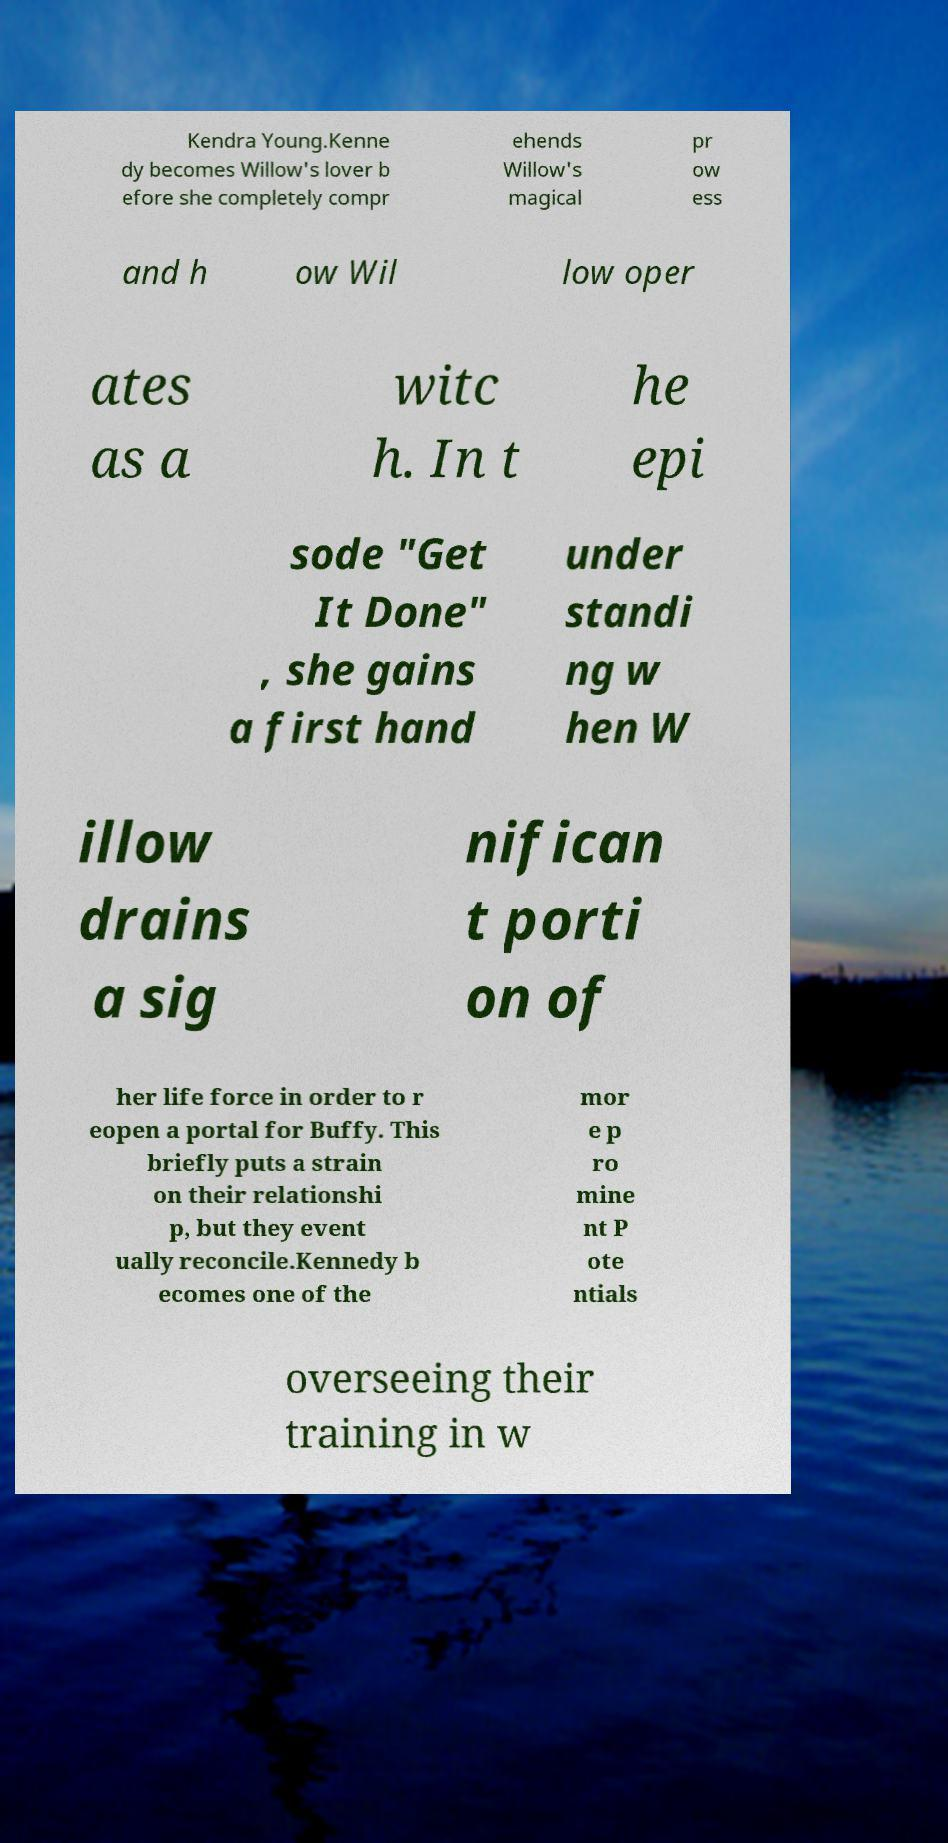For documentation purposes, I need the text within this image transcribed. Could you provide that? Kendra Young.Kenne dy becomes Willow's lover b efore she completely compr ehends Willow's magical pr ow ess and h ow Wil low oper ates as a witc h. In t he epi sode "Get It Done" , she gains a first hand under standi ng w hen W illow drains a sig nifican t porti on of her life force in order to r eopen a portal for Buffy. This briefly puts a strain on their relationshi p, but they event ually reconcile.Kennedy b ecomes one of the mor e p ro mine nt P ote ntials overseeing their training in w 